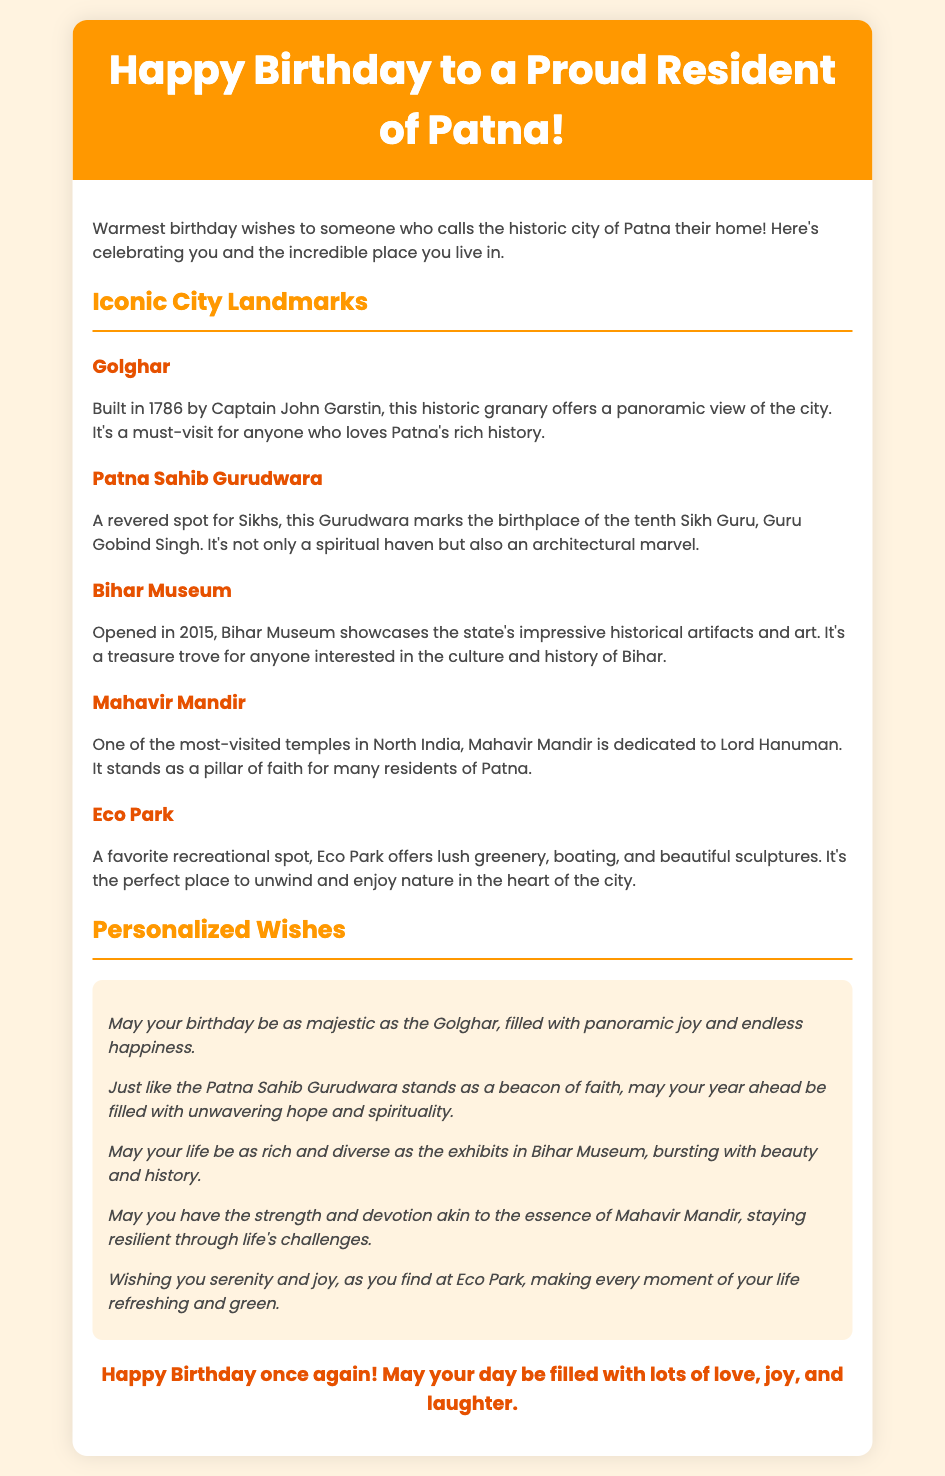What is the title of the greeting card? The title is prominently displayed in the header of the document, stating the occasion and recipient’s location.
Answer: Happy Birthday to a Proud Resident of Patna! How many iconic landmarks are mentioned? The document lists various landmarks in separate sections, allowing us to count them.
Answer: Five What does the Golghar offer? The description of Golghar highlights its significance and what visitors can experience.
Answer: Panoramic view Who is the tenth Sikh Guru? The document identifies the important figure associated with the Patna Sahib Gurudwara.
Answer: Guru Gobind Singh When was the Bihar Museum opened? This date is explicitly mentioned in the description of the museum.
Answer: 2015 What is Mahavir Mandir dedicated to? The document states the specific deity that Mahavir Mandir honors, highlighting its spiritual significance.
Answer: Lord Hanuman How many personalized wishes are provided? Each wish is presented individually, which allows counting them.
Answer: Five What type of recreational activities can one enjoy at Eco Park? The document lists features available at Eco Park that represent its recreational offerings.
Answer: Boating What is the overall theme of the greeting card? The theme can be inferred from the purpose and content of the card.
Answer: Birthday celebration 